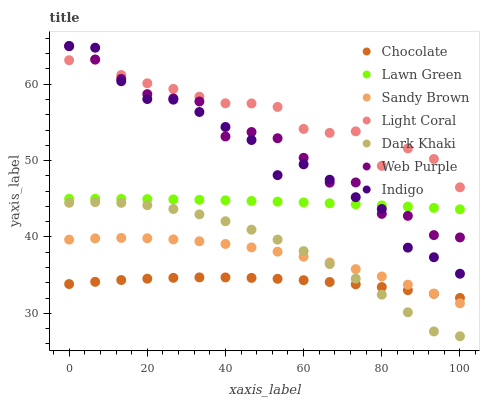Does Chocolate have the minimum area under the curve?
Answer yes or no. Yes. Does Light Coral have the maximum area under the curve?
Answer yes or no. Yes. Does Indigo have the minimum area under the curve?
Answer yes or no. No. Does Indigo have the maximum area under the curve?
Answer yes or no. No. Is Lawn Green the smoothest?
Answer yes or no. Yes. Is Indigo the roughest?
Answer yes or no. Yes. Is Chocolate the smoothest?
Answer yes or no. No. Is Chocolate the roughest?
Answer yes or no. No. Does Dark Khaki have the lowest value?
Answer yes or no. Yes. Does Indigo have the lowest value?
Answer yes or no. No. Does Indigo have the highest value?
Answer yes or no. Yes. Does Chocolate have the highest value?
Answer yes or no. No. Is Chocolate less than Light Coral?
Answer yes or no. Yes. Is Lawn Green greater than Dark Khaki?
Answer yes or no. Yes. Does Sandy Brown intersect Chocolate?
Answer yes or no. Yes. Is Sandy Brown less than Chocolate?
Answer yes or no. No. Is Sandy Brown greater than Chocolate?
Answer yes or no. No. Does Chocolate intersect Light Coral?
Answer yes or no. No. 